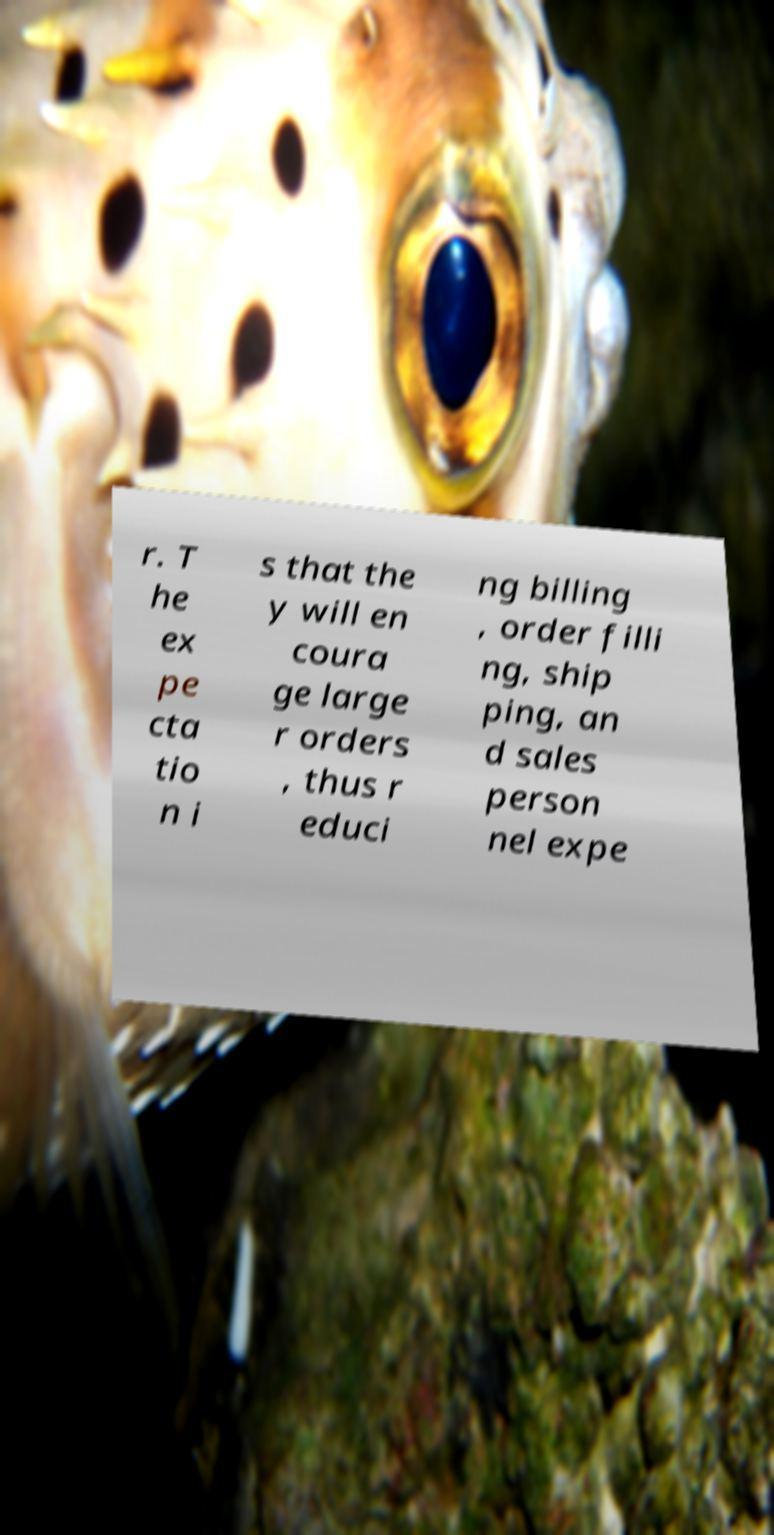Could you assist in decoding the text presented in this image and type it out clearly? r. T he ex pe cta tio n i s that the y will en coura ge large r orders , thus r educi ng billing , order filli ng, ship ping, an d sales person nel expe 